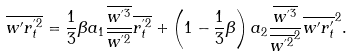<formula> <loc_0><loc_0><loc_500><loc_500>\overline { w ^ { \prime } r _ { t } ^ { ^ { \prime } 2 } } & = \frac { 1 } { 3 } \beta a _ { 1 } \frac { \overline { w ^ { ^ { \prime } 3 } } } { \overline { w ^ { ^ { \prime } 2 } } } \overline { r _ { t } ^ { ^ { \prime } 2 } } + \left ( 1 - \frac { 1 } { 3 } \beta \right ) a _ { 2 } \frac { \overline { w ^ { ^ { \prime } 3 } } } { \overline { w ^ { ^ { \prime } 2 } } ^ { 2 } } \overline { w ^ { \prime } r _ { t } ^ { \prime } } ^ { 2 } .</formula> 